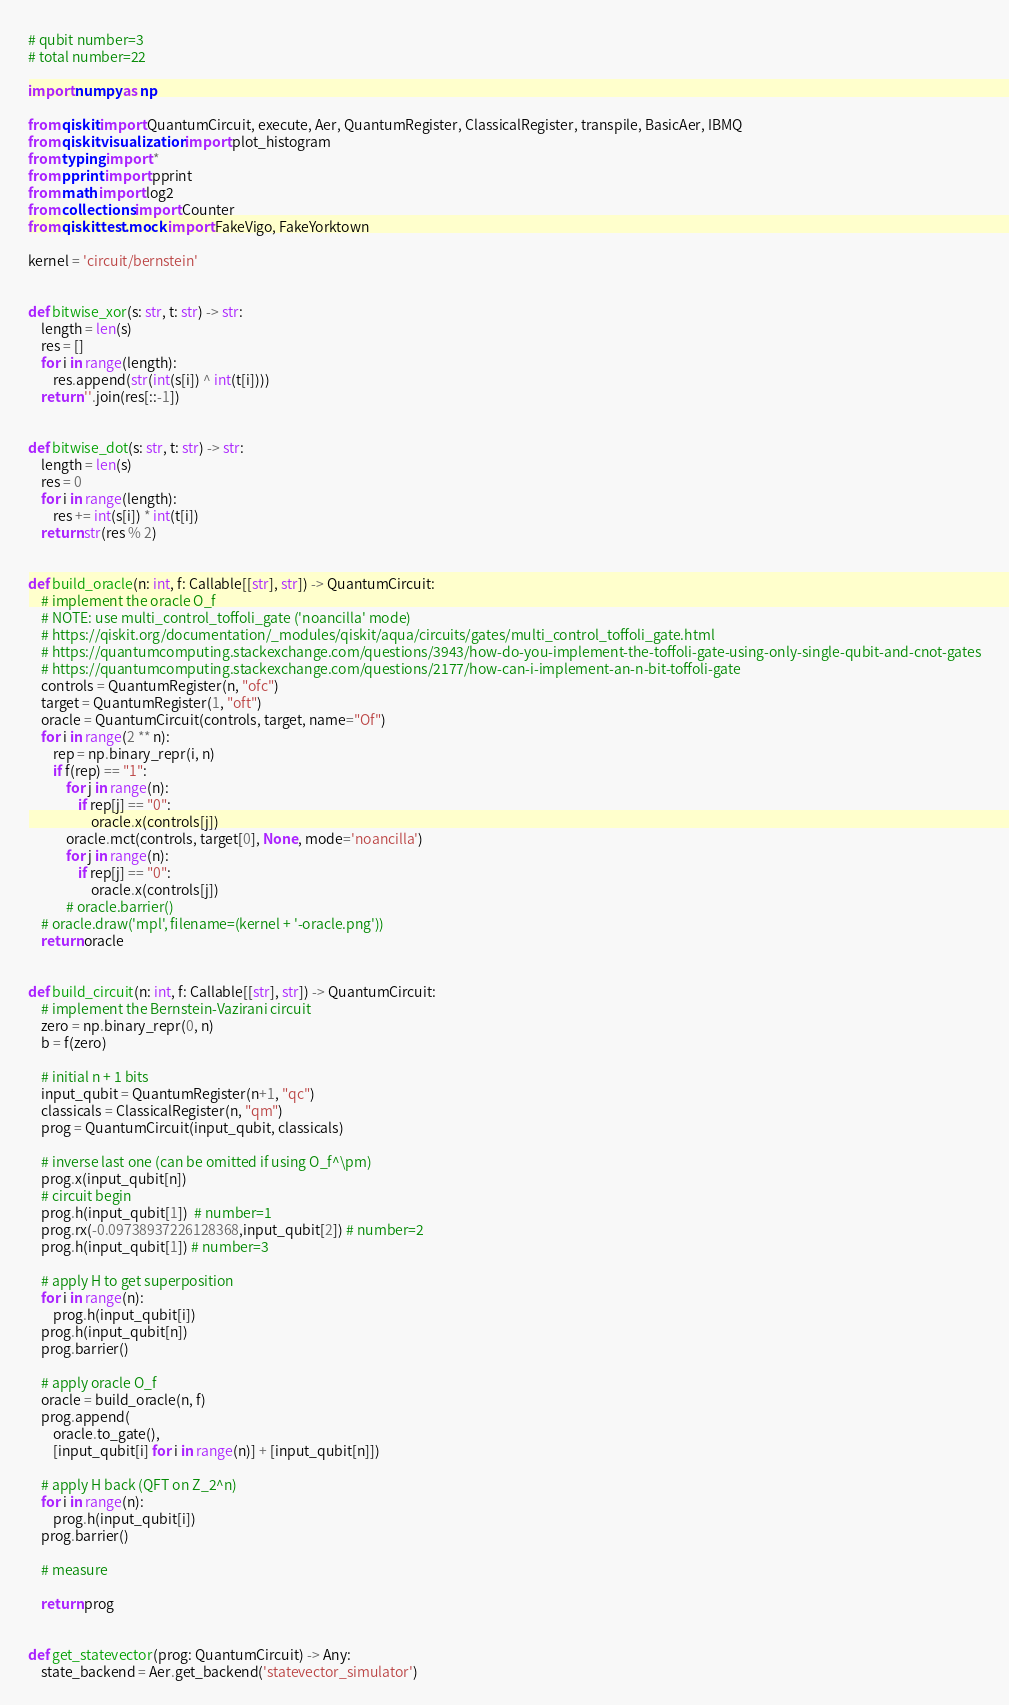<code> <loc_0><loc_0><loc_500><loc_500><_Python_># qubit number=3
# total number=22

import numpy as np

from qiskit import QuantumCircuit, execute, Aer, QuantumRegister, ClassicalRegister, transpile, BasicAer, IBMQ
from qiskit.visualization import plot_histogram
from typing import *
from pprint import pprint
from math import log2
from collections import Counter
from qiskit.test.mock import FakeVigo, FakeYorktown

kernel = 'circuit/bernstein'


def bitwise_xor(s: str, t: str) -> str:
    length = len(s)
    res = []
    for i in range(length):
        res.append(str(int(s[i]) ^ int(t[i])))
    return ''.join(res[::-1])


def bitwise_dot(s: str, t: str) -> str:
    length = len(s)
    res = 0
    for i in range(length):
        res += int(s[i]) * int(t[i])
    return str(res % 2)


def build_oracle(n: int, f: Callable[[str], str]) -> QuantumCircuit:
    # implement the oracle O_f
    # NOTE: use multi_control_toffoli_gate ('noancilla' mode)
    # https://qiskit.org/documentation/_modules/qiskit/aqua/circuits/gates/multi_control_toffoli_gate.html
    # https://quantumcomputing.stackexchange.com/questions/3943/how-do-you-implement-the-toffoli-gate-using-only-single-qubit-and-cnot-gates
    # https://quantumcomputing.stackexchange.com/questions/2177/how-can-i-implement-an-n-bit-toffoli-gate
    controls = QuantumRegister(n, "ofc")
    target = QuantumRegister(1, "oft")
    oracle = QuantumCircuit(controls, target, name="Of")
    for i in range(2 ** n):
        rep = np.binary_repr(i, n)
        if f(rep) == "1":
            for j in range(n):
                if rep[j] == "0":
                    oracle.x(controls[j])
            oracle.mct(controls, target[0], None, mode='noancilla')
            for j in range(n):
                if rep[j] == "0":
                    oracle.x(controls[j])
            # oracle.barrier()
    # oracle.draw('mpl', filename=(kernel + '-oracle.png'))
    return oracle


def build_circuit(n: int, f: Callable[[str], str]) -> QuantumCircuit:
    # implement the Bernstein-Vazirani circuit
    zero = np.binary_repr(0, n)
    b = f(zero)

    # initial n + 1 bits
    input_qubit = QuantumRegister(n+1, "qc")
    classicals = ClassicalRegister(n, "qm")
    prog = QuantumCircuit(input_qubit, classicals)

    # inverse last one (can be omitted if using O_f^\pm)
    prog.x(input_qubit[n])
    # circuit begin
    prog.h(input_qubit[1])  # number=1
    prog.rx(-0.09738937226128368,input_qubit[2]) # number=2
    prog.h(input_qubit[1]) # number=3

    # apply H to get superposition
    for i in range(n):
        prog.h(input_qubit[i])
    prog.h(input_qubit[n])
    prog.barrier()

    # apply oracle O_f
    oracle = build_oracle(n, f)
    prog.append(
        oracle.to_gate(),
        [input_qubit[i] for i in range(n)] + [input_qubit[n]])

    # apply H back (QFT on Z_2^n)
    for i in range(n):
        prog.h(input_qubit[i])
    prog.barrier()

    # measure

    return prog


def get_statevector(prog: QuantumCircuit) -> Any:
    state_backend = Aer.get_backend('statevector_simulator')</code> 